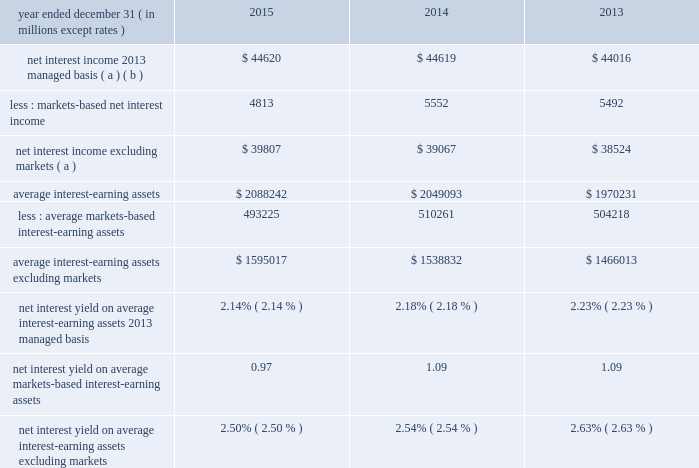Management 2019s discussion and analysis 82 jpmorgan chase & co./2015 annual report net interest income excluding markets-based activities ( formerly core net interest income ) in addition to reviewing net interest income on a managed basis , management also reviews net interest income excluding cib 2019s markets-based activities to assess the performance of the firm 2019s lending , investing ( including asset-liability management ) and deposit-raising activities .
The data presented below are non-gaap financial measures due to the exclusion of cib 2019s markets-based net interest income and related assets .
Management believes this exclusion provides investors and analysts with another measure by which to analyze the non-markets-related business trends of the firm and provides a comparable measure to other financial institutions that are primarily focused on lending , investing and deposit-raising activities .
Net interest income excluding cib markets-based activities data year ended december 31 , ( in millions , except rates ) 2015 2014 2013 net interest income 2013 managed basis ( a ) ( b ) $ 44620 $ 44619 $ 44016 less : markets-based net interest income 4813 5552 5492 net interest income excluding markets ( a ) $ 39807 $ 39067 $ 38524 average interest-earning assets $ 2088242 $ 2049093 $ 1970231 less : average markets- based interest-earning assets 493225 510261 504218 average interest- earning assets excluding markets $ 1595017 $ 1538832 $ 1466013 net interest yield on average interest-earning assets 2013 managed basis 2.14% ( 2.14 % ) 2.18% ( 2.18 % ) 2.23% ( 2.23 % ) net interest yield on average markets-based interest-earning assets 0.97 1.09 1.09 net interest yield on average interest-earning assets excluding markets 2.50% ( 2.50 % ) 2.54% ( 2.54 % ) 2.63% ( 2.63 % ) ( a ) interest includes the effect of related hedging derivatives .
Taxable-equivalent amounts are used where applicable .
( b ) for a reconciliation of net interest income on a reported and managed basis , see reconciliation from the firm 2019s reported u.s .
Gaap results to managed basis on page 80 .
2015 compared with 2014 net interest income excluding cib 2019s markets-based activities increased by $ 740 million in 2015 to $ 39.8 billion , and average interest-earning assets increased by $ 56.2 billion to $ 1.6 trillion .
The increase in net interest income in 2015 predominantly reflected higher average loan balances and lower interest expense on deposits .
The increase was partially offset by lower loan yields and lower investment securities net interest income .
The increase in average interest-earning assets largely reflected the impact of higher average deposits with banks .
These changes in net interest income and interest-earning assets resulted in the net interest yield decreasing by 4 basis points to 2.50% ( 2.50 % ) for 2014 compared with 2013 net interest income excluding cib 2019s markets-based activities increased by $ 543 million in 2014 to $ 39.1 billion , and average interest-earning assets increased by $ 72.8 billion to $ 1.5 trillion .
The increase in net interest income in 2014 predominantly reflected higher yields on investment securities , the impact of lower interest expense , and higher average loan balances .
The increase was partially offset by lower yields on loans due to the run-off of higher-yielding loans and new originations of lower-yielding loans .
The increase in average interest-earning assets largely reflected the impact of higher average balance of deposits with banks .
These changes in net interest income and interest- earning assets resulted in the net interest yield decreasing by 9 basis points to 2.54% ( 2.54 % ) for 2014. .
Management 2019s discussion and analysis 82 jpmorgan chase & co./2015 annual report net interest income excluding markets-based activities ( formerly core net interest income ) in addition to reviewing net interest income on a managed basis , management also reviews net interest income excluding cib 2019s markets-based activities to assess the performance of the firm 2019s lending , investing ( including asset-liability management ) and deposit-raising activities .
The data presented below are non-gaap financial measures due to the exclusion of cib 2019s markets-based net interest income and related assets .
Management believes this exclusion provides investors and analysts with another measure by which to analyze the non-markets-related business trends of the firm and provides a comparable measure to other financial institutions that are primarily focused on lending , investing and deposit-raising activities .
Net interest income excluding cib markets-based activities data year ended december 31 , ( in millions , except rates ) 2015 2014 2013 net interest income 2013 managed basis ( a ) ( b ) $ 44620 $ 44619 $ 44016 less : markets-based net interest income 4813 5552 5492 net interest income excluding markets ( a ) $ 39807 $ 39067 $ 38524 average interest-earning assets $ 2088242 $ 2049093 $ 1970231 less : average markets- based interest-earning assets 493225 510261 504218 average interest- earning assets excluding markets $ 1595017 $ 1538832 $ 1466013 net interest yield on average interest-earning assets 2013 managed basis 2.14% ( 2.14 % ) 2.18% ( 2.18 % ) 2.23% ( 2.23 % ) net interest yield on average markets-based interest-earning assets 0.97 1.09 1.09 net interest yield on average interest-earning assets excluding markets 2.50% ( 2.50 % ) 2.54% ( 2.54 % ) 2.63% ( 2.63 % ) ( a ) interest includes the effect of related hedging derivatives .
Taxable-equivalent amounts are used where applicable .
( b ) for a reconciliation of net interest income on a reported and managed basis , see reconciliation from the firm 2019s reported u.s .
Gaap results to managed basis on page 80 .
2015 compared with 2014 net interest income excluding cib 2019s markets-based activities increased by $ 740 million in 2015 to $ 39.8 billion , and average interest-earning assets increased by $ 56.2 billion to $ 1.6 trillion .
The increase in net interest income in 2015 predominantly reflected higher average loan balances and lower interest expense on deposits .
The increase was partially offset by lower loan yields and lower investment securities net interest income .
The increase in average interest-earning assets largely reflected the impact of higher average deposits with banks .
These changes in net interest income and interest-earning assets resulted in the net interest yield decreasing by 4 basis points to 2.50% ( 2.50 % ) for 2014 compared with 2013 net interest income excluding cib 2019s markets-based activities increased by $ 543 million in 2014 to $ 39.1 billion , and average interest-earning assets increased by $ 72.8 billion to $ 1.5 trillion .
The increase in net interest income in 2014 predominantly reflected higher yields on investment securities , the impact of lower interest expense , and higher average loan balances .
The increase was partially offset by lower yields on loans due to the run-off of higher-yielding loans and new originations of lower-yielding loans .
The increase in average interest-earning assets largely reflected the impact of higher average balance of deposits with banks .
These changes in net interest income and interest- earning assets resulted in the net interest yield decreasing by 9 basis points to 2.54% ( 2.54 % ) for 2014. .
Assuming a 1% ( 1 % ) increase in the 2015 interest yield on managed interest-earning assets , what would the three year average yield improve to? 
Computations: ((((2.14 - 1) + 2.18) + 2.23) / 3)
Answer: 1.85. Management 2019s discussion and analysis 82 jpmorgan chase & co./2015 annual report net interest income excluding markets-based activities ( formerly core net interest income ) in addition to reviewing net interest income on a managed basis , management also reviews net interest income excluding cib 2019s markets-based activities to assess the performance of the firm 2019s lending , investing ( including asset-liability management ) and deposit-raising activities .
The data presented below are non-gaap financial measures due to the exclusion of cib 2019s markets-based net interest income and related assets .
Management believes this exclusion provides investors and analysts with another measure by which to analyze the non-markets-related business trends of the firm and provides a comparable measure to other financial institutions that are primarily focused on lending , investing and deposit-raising activities .
Net interest income excluding cib markets-based activities data year ended december 31 , ( in millions , except rates ) 2015 2014 2013 net interest income 2013 managed basis ( a ) ( b ) $ 44620 $ 44619 $ 44016 less : markets-based net interest income 4813 5552 5492 net interest income excluding markets ( a ) $ 39807 $ 39067 $ 38524 average interest-earning assets $ 2088242 $ 2049093 $ 1970231 less : average markets- based interest-earning assets 493225 510261 504218 average interest- earning assets excluding markets $ 1595017 $ 1538832 $ 1466013 net interest yield on average interest-earning assets 2013 managed basis 2.14% ( 2.14 % ) 2.18% ( 2.18 % ) 2.23% ( 2.23 % ) net interest yield on average markets-based interest-earning assets 0.97 1.09 1.09 net interest yield on average interest-earning assets excluding markets 2.50% ( 2.50 % ) 2.54% ( 2.54 % ) 2.63% ( 2.63 % ) ( a ) interest includes the effect of related hedging derivatives .
Taxable-equivalent amounts are used where applicable .
( b ) for a reconciliation of net interest income on a reported and managed basis , see reconciliation from the firm 2019s reported u.s .
Gaap results to managed basis on page 80 .
2015 compared with 2014 net interest income excluding cib 2019s markets-based activities increased by $ 740 million in 2015 to $ 39.8 billion , and average interest-earning assets increased by $ 56.2 billion to $ 1.6 trillion .
The increase in net interest income in 2015 predominantly reflected higher average loan balances and lower interest expense on deposits .
The increase was partially offset by lower loan yields and lower investment securities net interest income .
The increase in average interest-earning assets largely reflected the impact of higher average deposits with banks .
These changes in net interest income and interest-earning assets resulted in the net interest yield decreasing by 4 basis points to 2.50% ( 2.50 % ) for 2014 compared with 2013 net interest income excluding cib 2019s markets-based activities increased by $ 543 million in 2014 to $ 39.1 billion , and average interest-earning assets increased by $ 72.8 billion to $ 1.5 trillion .
The increase in net interest income in 2014 predominantly reflected higher yields on investment securities , the impact of lower interest expense , and higher average loan balances .
The increase was partially offset by lower yields on loans due to the run-off of higher-yielding loans and new originations of lower-yielding loans .
The increase in average interest-earning assets largely reflected the impact of higher average balance of deposits with banks .
These changes in net interest income and interest- earning assets resulted in the net interest yield decreasing by 9 basis points to 2.54% ( 2.54 % ) for 2014. .
Management 2019s discussion and analysis 82 jpmorgan chase & co./2015 annual report net interest income excluding markets-based activities ( formerly core net interest income ) in addition to reviewing net interest income on a managed basis , management also reviews net interest income excluding cib 2019s markets-based activities to assess the performance of the firm 2019s lending , investing ( including asset-liability management ) and deposit-raising activities .
The data presented below are non-gaap financial measures due to the exclusion of cib 2019s markets-based net interest income and related assets .
Management believes this exclusion provides investors and analysts with another measure by which to analyze the non-markets-related business trends of the firm and provides a comparable measure to other financial institutions that are primarily focused on lending , investing and deposit-raising activities .
Net interest income excluding cib markets-based activities data year ended december 31 , ( in millions , except rates ) 2015 2014 2013 net interest income 2013 managed basis ( a ) ( b ) $ 44620 $ 44619 $ 44016 less : markets-based net interest income 4813 5552 5492 net interest income excluding markets ( a ) $ 39807 $ 39067 $ 38524 average interest-earning assets $ 2088242 $ 2049093 $ 1970231 less : average markets- based interest-earning assets 493225 510261 504218 average interest- earning assets excluding markets $ 1595017 $ 1538832 $ 1466013 net interest yield on average interest-earning assets 2013 managed basis 2.14% ( 2.14 % ) 2.18% ( 2.18 % ) 2.23% ( 2.23 % ) net interest yield on average markets-based interest-earning assets 0.97 1.09 1.09 net interest yield on average interest-earning assets excluding markets 2.50% ( 2.50 % ) 2.54% ( 2.54 % ) 2.63% ( 2.63 % ) ( a ) interest includes the effect of related hedging derivatives .
Taxable-equivalent amounts are used where applicable .
( b ) for a reconciliation of net interest income on a reported and managed basis , see reconciliation from the firm 2019s reported u.s .
Gaap results to managed basis on page 80 .
2015 compared with 2014 net interest income excluding cib 2019s markets-based activities increased by $ 740 million in 2015 to $ 39.8 billion , and average interest-earning assets increased by $ 56.2 billion to $ 1.6 trillion .
The increase in net interest income in 2015 predominantly reflected higher average loan balances and lower interest expense on deposits .
The increase was partially offset by lower loan yields and lower investment securities net interest income .
The increase in average interest-earning assets largely reflected the impact of higher average deposits with banks .
These changes in net interest income and interest-earning assets resulted in the net interest yield decreasing by 4 basis points to 2.50% ( 2.50 % ) for 2014 compared with 2013 net interest income excluding cib 2019s markets-based activities increased by $ 543 million in 2014 to $ 39.1 billion , and average interest-earning assets increased by $ 72.8 billion to $ 1.5 trillion .
The increase in net interest income in 2014 predominantly reflected higher yields on investment securities , the impact of lower interest expense , and higher average loan balances .
The increase was partially offset by lower yields on loans due to the run-off of higher-yielding loans and new originations of lower-yielding loans .
The increase in average interest-earning assets largely reflected the impact of higher average balance of deposits with banks .
These changes in net interest income and interest- earning assets resulted in the net interest yield decreasing by 9 basis points to 2.54% ( 2.54 % ) for 2014. .
In 2015 what was the percent of the markets-based net interest income to the net interest income 2013 managed basis? 
Computations: (4813 / 44620)
Answer: 0.10787. 